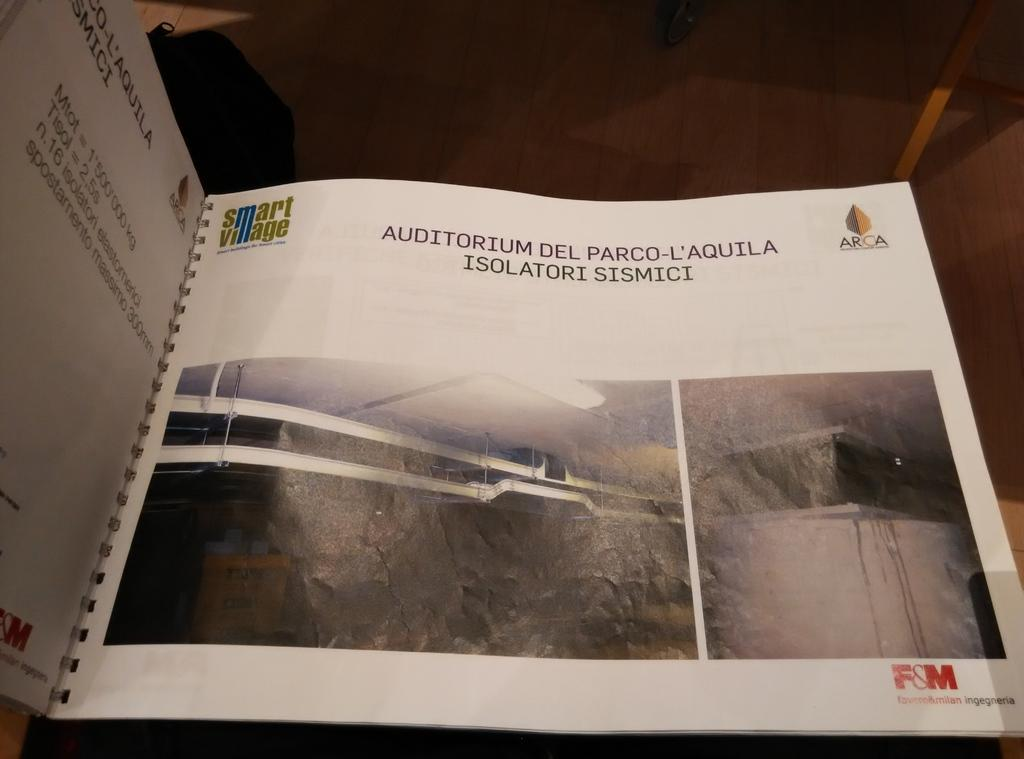<image>
Present a compact description of the photo's key features. An open book with some pictures and the word Auditorium at the top left. 